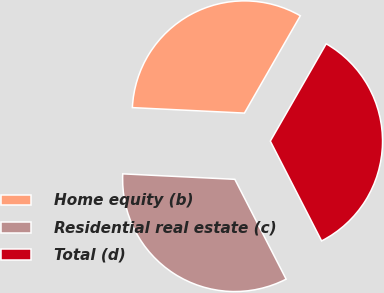Convert chart to OTSL. <chart><loc_0><loc_0><loc_500><loc_500><pie_chart><fcel>Home equity (b)<fcel>Residential real estate (c)<fcel>Total (d)<nl><fcel>32.52%<fcel>33.33%<fcel>34.15%<nl></chart> 